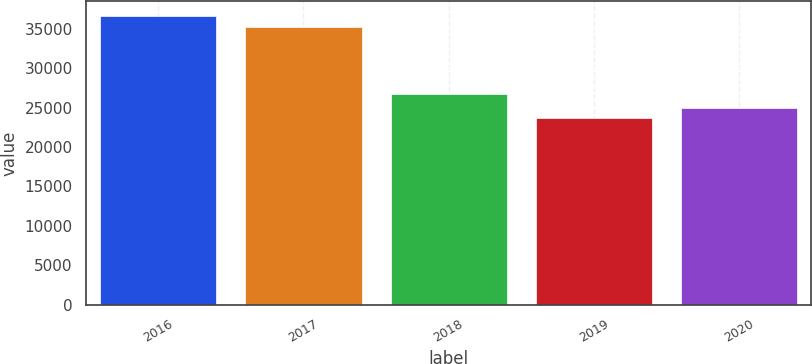<chart> <loc_0><loc_0><loc_500><loc_500><bar_chart><fcel>2016<fcel>2017<fcel>2018<fcel>2019<fcel>2020<nl><fcel>36648<fcel>35256<fcel>26689<fcel>23643<fcel>24943.5<nl></chart> 